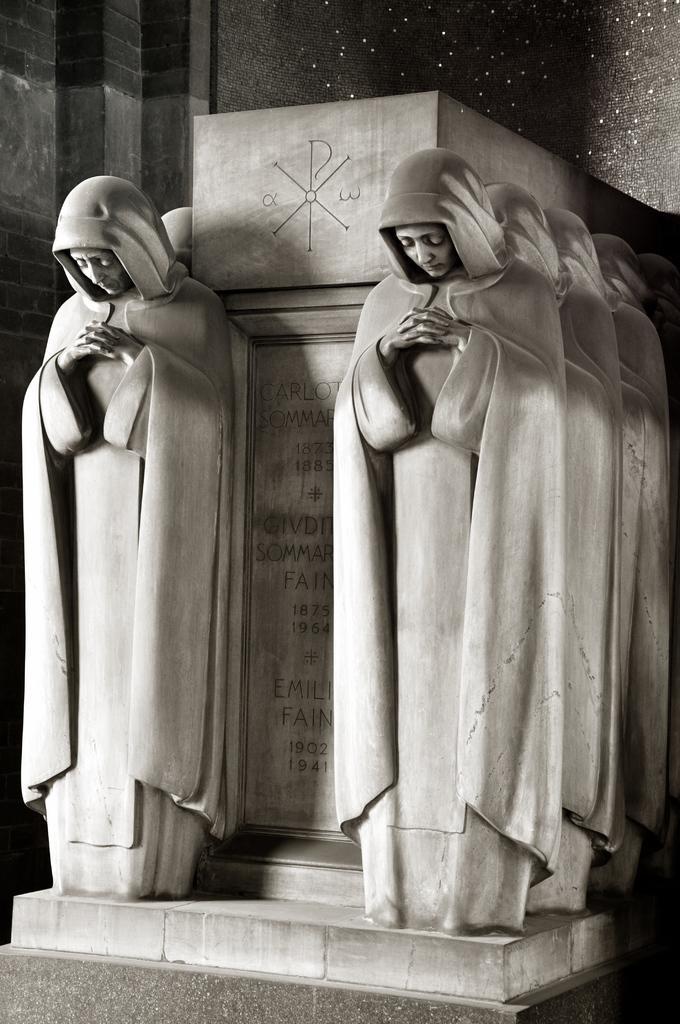In one or two sentences, can you explain what this image depicts? This picture shows stone carving and we see statues hand carved text on the stone. 